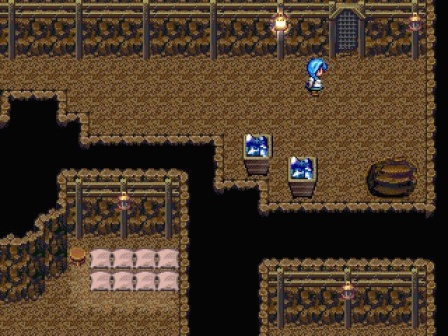What do you see happening in this image? The image depicts a scene from a pixel art style video game, resembling a traditional RPG dungeon crawler in a cave setting. A character with distinctive blue hair is seen moving towards the right. This indicates a progression or exploration aspect typical in dungeon crawlers. Also notable are the two treasure chests on the left, which may contain items or power-ups essential for the game progression. Additionally, there's a barrel and a bed that might serve as storage or a resting point, suggesting gameplay mechanics involving resource management or health regeneration. The presence of several torches provides lighting, enhancing the moody, atmospheric quality of the dungeon setting, while the dark area to the right suggests unexplored paths that could hold dangers or secrets. 